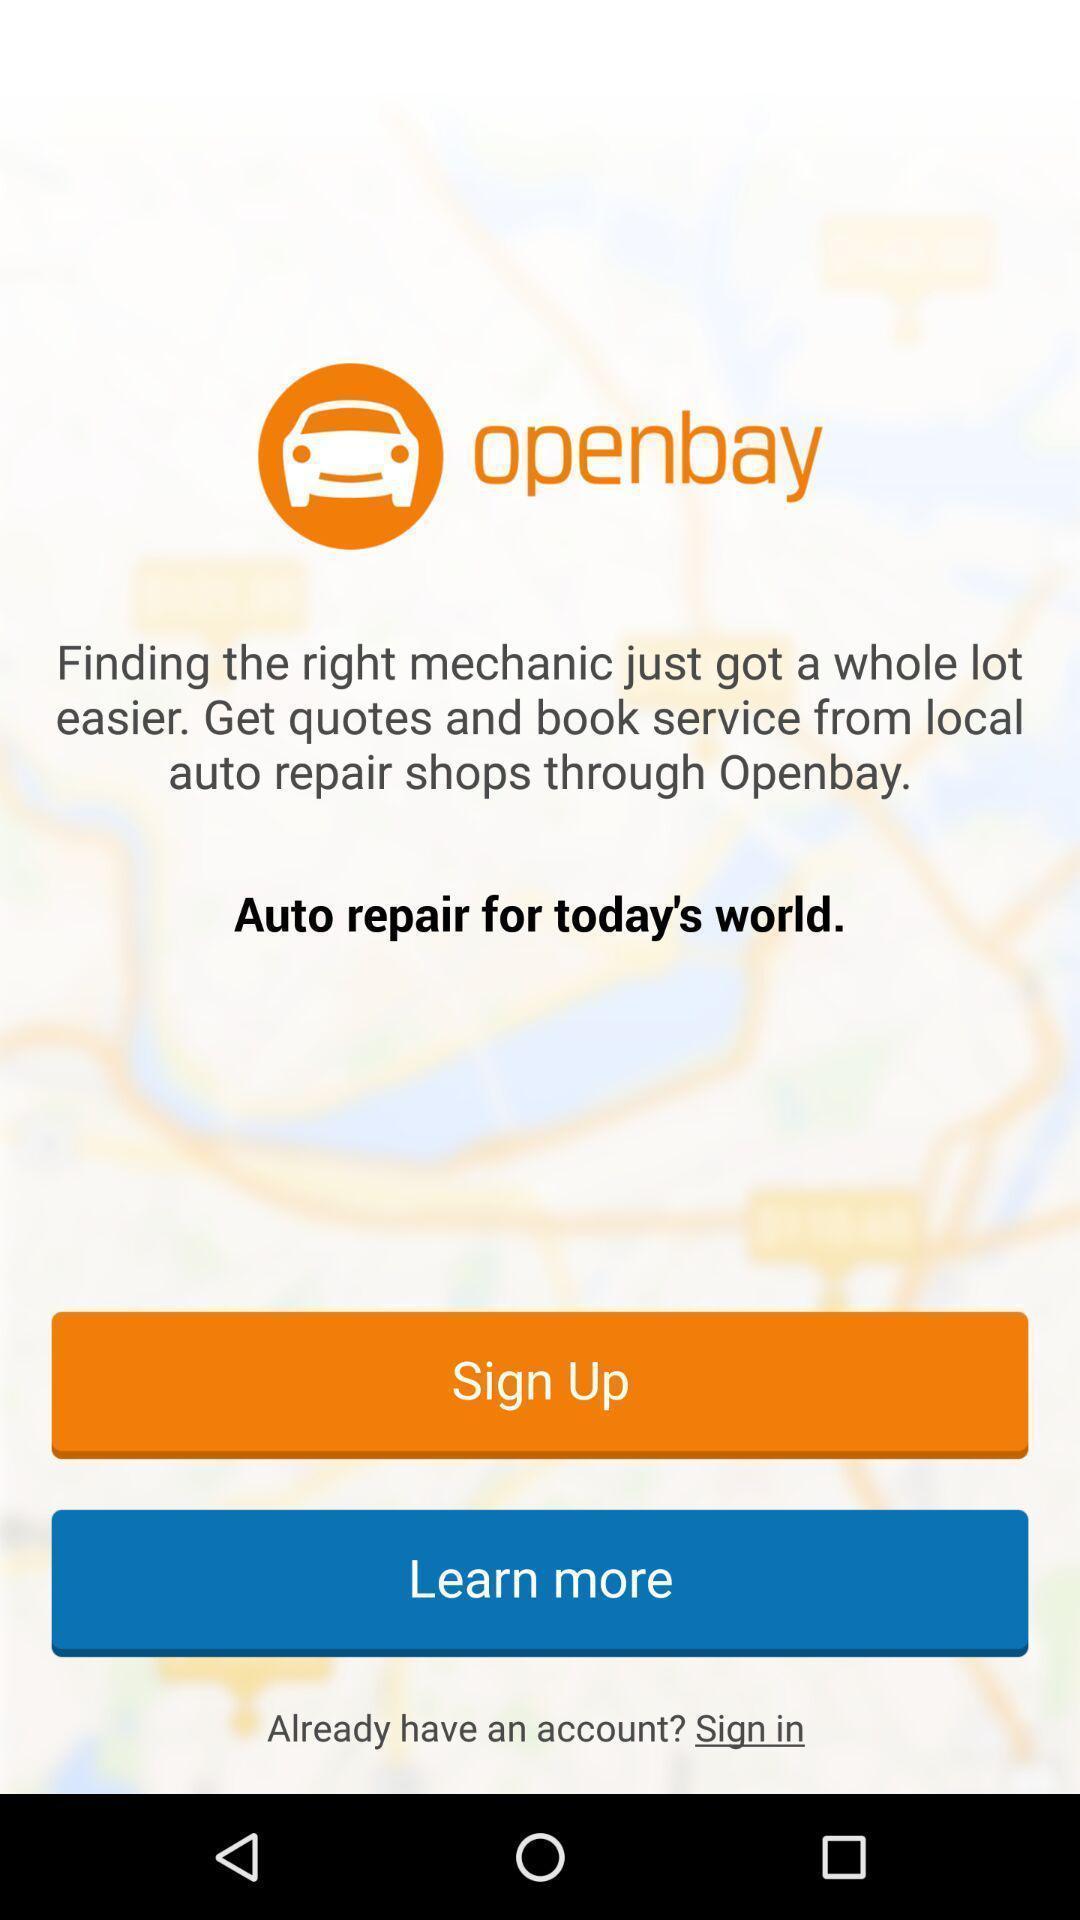Provide a textual representation of this image. Welcome page to sign in of an automobile repair application. 